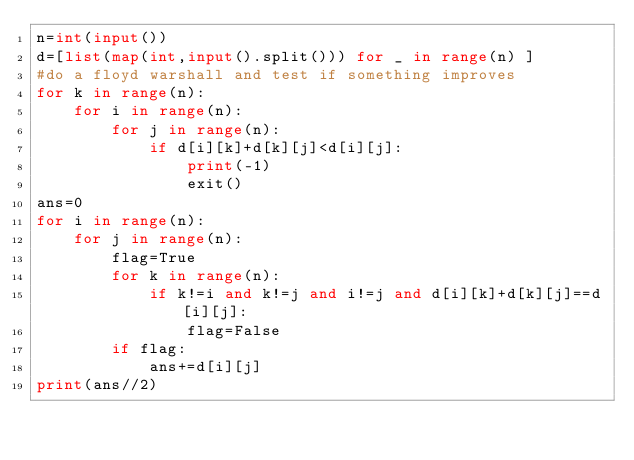<code> <loc_0><loc_0><loc_500><loc_500><_Python_>n=int(input())
d=[list(map(int,input().split())) for _ in range(n) ]
#do a floyd warshall and test if something improves 
for k in range(n):
    for i in range(n):
        for j in range(n):
            if d[i][k]+d[k][j]<d[i][j]:
                print(-1)
                exit()
ans=0
for i in range(n):
    for j in range(n):
        flag=True
        for k in range(n):
            if k!=i and k!=j and i!=j and d[i][k]+d[k][j]==d[i][j]:
                flag=False
        if flag:
            ans+=d[i][j]
print(ans//2)

</code> 